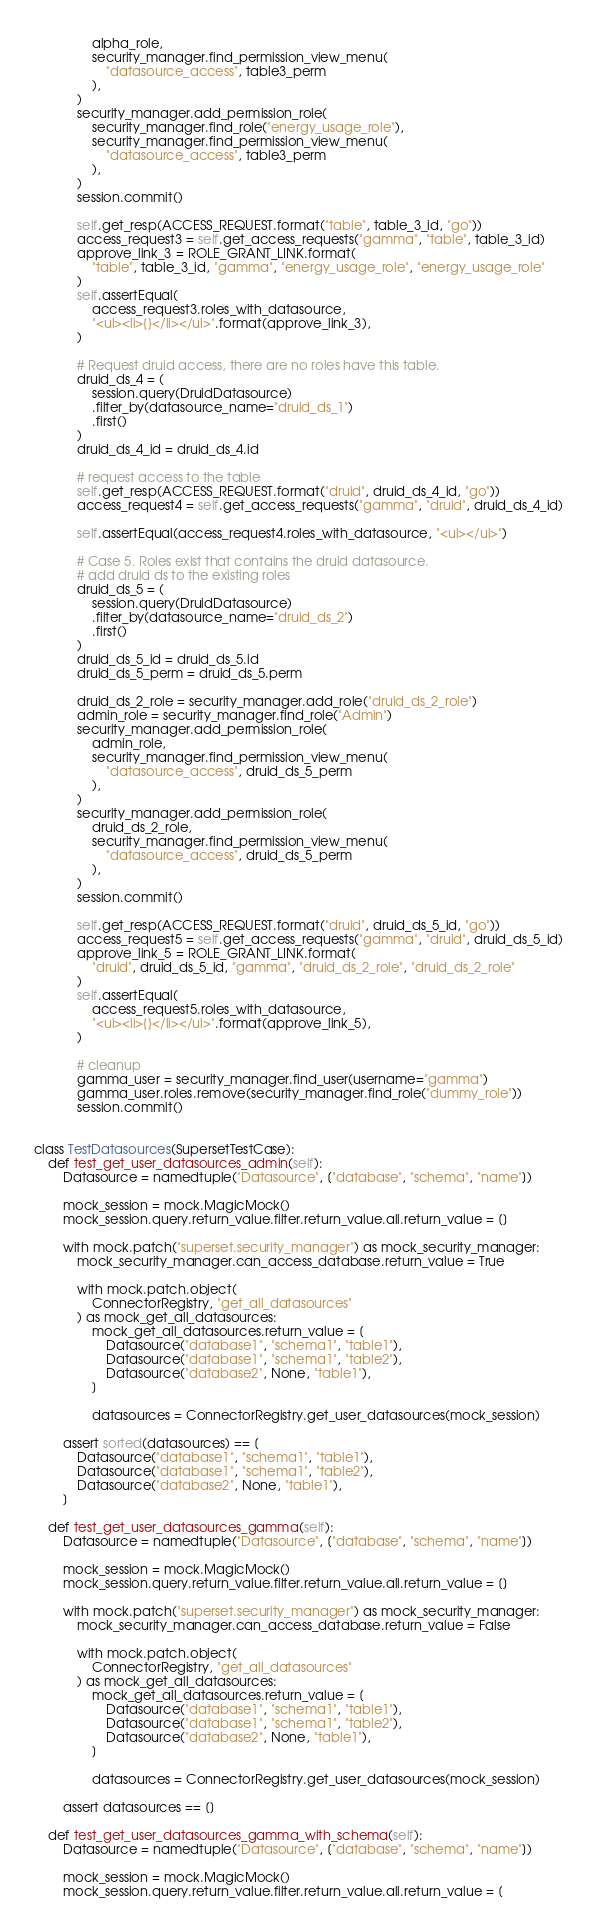<code> <loc_0><loc_0><loc_500><loc_500><_Python_>                alpha_role,
                security_manager.find_permission_view_menu(
                    "datasource_access", table3_perm
                ),
            )
            security_manager.add_permission_role(
                security_manager.find_role("energy_usage_role"),
                security_manager.find_permission_view_menu(
                    "datasource_access", table3_perm
                ),
            )
            session.commit()

            self.get_resp(ACCESS_REQUEST.format("table", table_3_id, "go"))
            access_request3 = self.get_access_requests("gamma", "table", table_3_id)
            approve_link_3 = ROLE_GRANT_LINK.format(
                "table", table_3_id, "gamma", "energy_usage_role", "energy_usage_role"
            )
            self.assertEqual(
                access_request3.roles_with_datasource,
                "<ul><li>{}</li></ul>".format(approve_link_3),
            )

            # Request druid access, there are no roles have this table.
            druid_ds_4 = (
                session.query(DruidDatasource)
                .filter_by(datasource_name="druid_ds_1")
                .first()
            )
            druid_ds_4_id = druid_ds_4.id

            # request access to the table
            self.get_resp(ACCESS_REQUEST.format("druid", druid_ds_4_id, "go"))
            access_request4 = self.get_access_requests("gamma", "druid", druid_ds_4_id)

            self.assertEqual(access_request4.roles_with_datasource, "<ul></ul>")

            # Case 5. Roles exist that contains the druid datasource.
            # add druid ds to the existing roles
            druid_ds_5 = (
                session.query(DruidDatasource)
                .filter_by(datasource_name="druid_ds_2")
                .first()
            )
            druid_ds_5_id = druid_ds_5.id
            druid_ds_5_perm = druid_ds_5.perm

            druid_ds_2_role = security_manager.add_role("druid_ds_2_role")
            admin_role = security_manager.find_role("Admin")
            security_manager.add_permission_role(
                admin_role,
                security_manager.find_permission_view_menu(
                    "datasource_access", druid_ds_5_perm
                ),
            )
            security_manager.add_permission_role(
                druid_ds_2_role,
                security_manager.find_permission_view_menu(
                    "datasource_access", druid_ds_5_perm
                ),
            )
            session.commit()

            self.get_resp(ACCESS_REQUEST.format("druid", druid_ds_5_id, "go"))
            access_request5 = self.get_access_requests("gamma", "druid", druid_ds_5_id)
            approve_link_5 = ROLE_GRANT_LINK.format(
                "druid", druid_ds_5_id, "gamma", "druid_ds_2_role", "druid_ds_2_role"
            )
            self.assertEqual(
                access_request5.roles_with_datasource,
                "<ul><li>{}</li></ul>".format(approve_link_5),
            )

            # cleanup
            gamma_user = security_manager.find_user(username="gamma")
            gamma_user.roles.remove(security_manager.find_role("dummy_role"))
            session.commit()


class TestDatasources(SupersetTestCase):
    def test_get_user_datasources_admin(self):
        Datasource = namedtuple("Datasource", ["database", "schema", "name"])

        mock_session = mock.MagicMock()
        mock_session.query.return_value.filter.return_value.all.return_value = []

        with mock.patch("superset.security_manager") as mock_security_manager:
            mock_security_manager.can_access_database.return_value = True

            with mock.patch.object(
                ConnectorRegistry, "get_all_datasources"
            ) as mock_get_all_datasources:
                mock_get_all_datasources.return_value = [
                    Datasource("database1", "schema1", "table1"),
                    Datasource("database1", "schema1", "table2"),
                    Datasource("database2", None, "table1"),
                ]

                datasources = ConnectorRegistry.get_user_datasources(mock_session)

        assert sorted(datasources) == [
            Datasource("database1", "schema1", "table1"),
            Datasource("database1", "schema1", "table2"),
            Datasource("database2", None, "table1"),
        ]

    def test_get_user_datasources_gamma(self):
        Datasource = namedtuple("Datasource", ["database", "schema", "name"])

        mock_session = mock.MagicMock()
        mock_session.query.return_value.filter.return_value.all.return_value = []

        with mock.patch("superset.security_manager") as mock_security_manager:
            mock_security_manager.can_access_database.return_value = False

            with mock.patch.object(
                ConnectorRegistry, "get_all_datasources"
            ) as mock_get_all_datasources:
                mock_get_all_datasources.return_value = [
                    Datasource("database1", "schema1", "table1"),
                    Datasource("database1", "schema1", "table2"),
                    Datasource("database2", None, "table1"),
                ]

                datasources = ConnectorRegistry.get_user_datasources(mock_session)

        assert datasources == []

    def test_get_user_datasources_gamma_with_schema(self):
        Datasource = namedtuple("Datasource", ["database", "schema", "name"])

        mock_session = mock.MagicMock()
        mock_session.query.return_value.filter.return_value.all.return_value = [</code> 